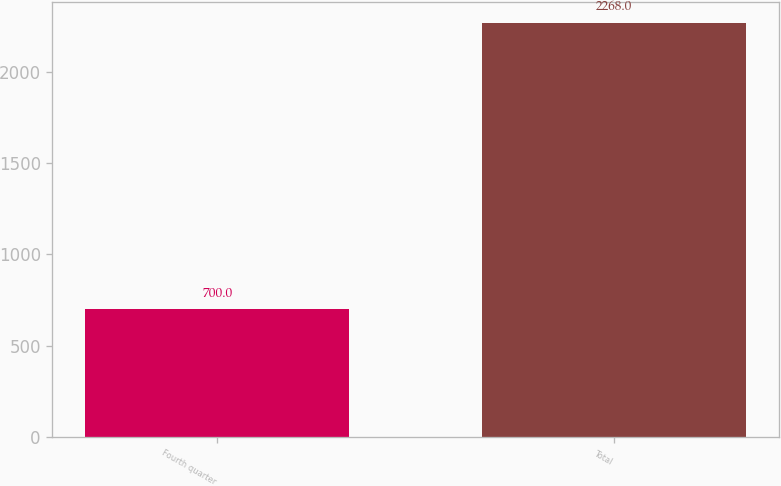Convert chart to OTSL. <chart><loc_0><loc_0><loc_500><loc_500><bar_chart><fcel>Fourth quarter<fcel>Total<nl><fcel>700<fcel>2268<nl></chart> 